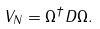<formula> <loc_0><loc_0><loc_500><loc_500>V _ { N } = \Omega ^ { \dag } D \Omega .</formula> 